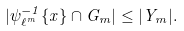<formula> <loc_0><loc_0><loc_500><loc_500>| \psi _ { \ell ^ { m } } ^ { - 1 } \{ x \} \cap G _ { m } | \leq | Y _ { m } | .</formula> 